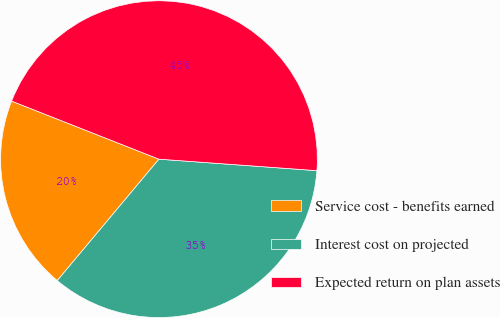Convert chart. <chart><loc_0><loc_0><loc_500><loc_500><pie_chart><fcel>Service cost - benefits earned<fcel>Interest cost on projected<fcel>Expected return on plan assets<nl><fcel>19.88%<fcel>34.94%<fcel>45.18%<nl></chart> 